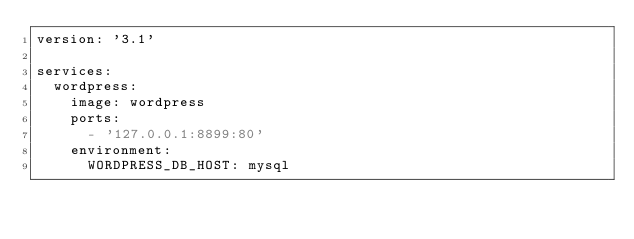<code> <loc_0><loc_0><loc_500><loc_500><_YAML_>version: '3.1'

services:
  wordpress:
    image: wordpress
    ports:
      - '127.0.0.1:8899:80'
    environment:
      WORDPRESS_DB_HOST: mysql</code> 